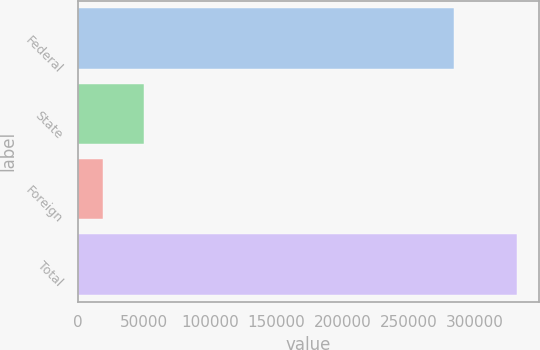<chart> <loc_0><loc_0><loc_500><loc_500><bar_chart><fcel>Federal<fcel>State<fcel>Foreign<fcel>Total<nl><fcel>284489<fcel>50290<fcel>19017<fcel>331747<nl></chart> 